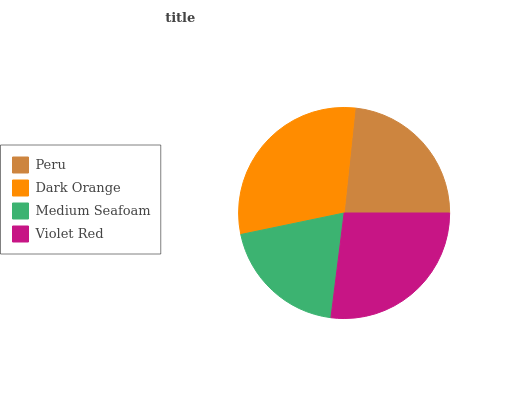Is Medium Seafoam the minimum?
Answer yes or no. Yes. Is Dark Orange the maximum?
Answer yes or no. Yes. Is Dark Orange the minimum?
Answer yes or no. No. Is Medium Seafoam the maximum?
Answer yes or no. No. Is Dark Orange greater than Medium Seafoam?
Answer yes or no. Yes. Is Medium Seafoam less than Dark Orange?
Answer yes or no. Yes. Is Medium Seafoam greater than Dark Orange?
Answer yes or no. No. Is Dark Orange less than Medium Seafoam?
Answer yes or no. No. Is Violet Red the high median?
Answer yes or no. Yes. Is Peru the low median?
Answer yes or no. Yes. Is Medium Seafoam the high median?
Answer yes or no. No. Is Dark Orange the low median?
Answer yes or no. No. 